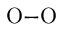<formula> <loc_0><loc_0><loc_500><loc_500>O { - } O</formula> 